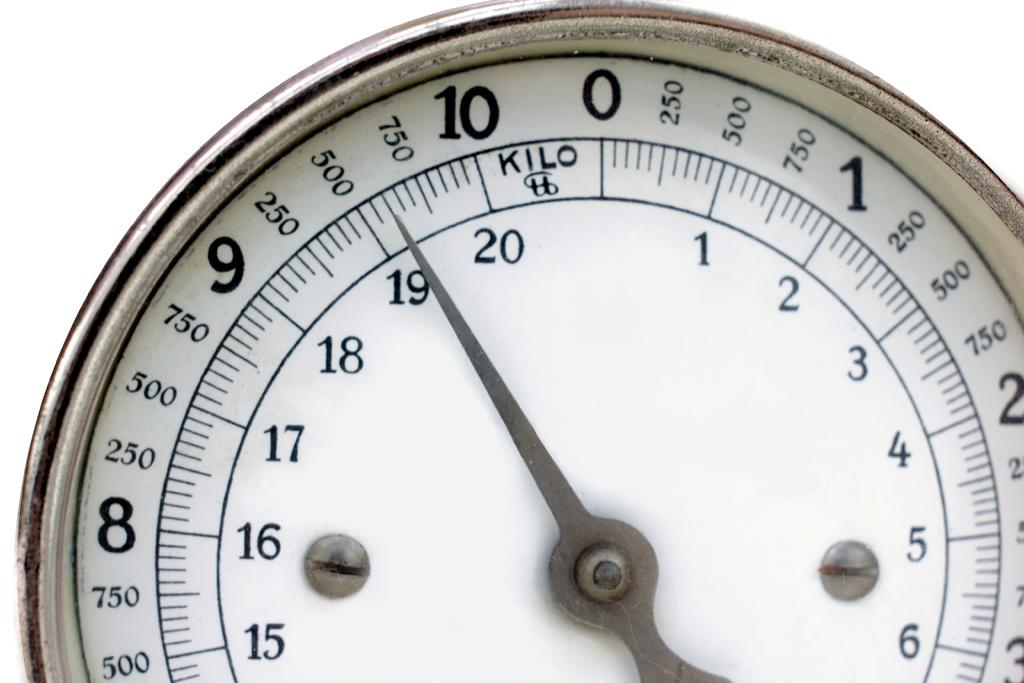<image>
Share a concise interpretation of the image provided. A white scale with kilos whose arrow is pointed just past the 19 